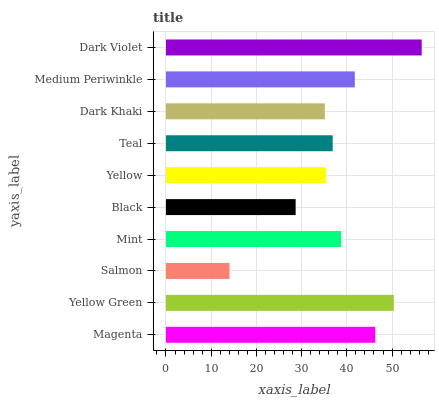Is Salmon the minimum?
Answer yes or no. Yes. Is Dark Violet the maximum?
Answer yes or no. Yes. Is Yellow Green the minimum?
Answer yes or no. No. Is Yellow Green the maximum?
Answer yes or no. No. Is Yellow Green greater than Magenta?
Answer yes or no. Yes. Is Magenta less than Yellow Green?
Answer yes or no. Yes. Is Magenta greater than Yellow Green?
Answer yes or no. No. Is Yellow Green less than Magenta?
Answer yes or no. No. Is Mint the high median?
Answer yes or no. Yes. Is Teal the low median?
Answer yes or no. Yes. Is Salmon the high median?
Answer yes or no. No. Is Black the low median?
Answer yes or no. No. 